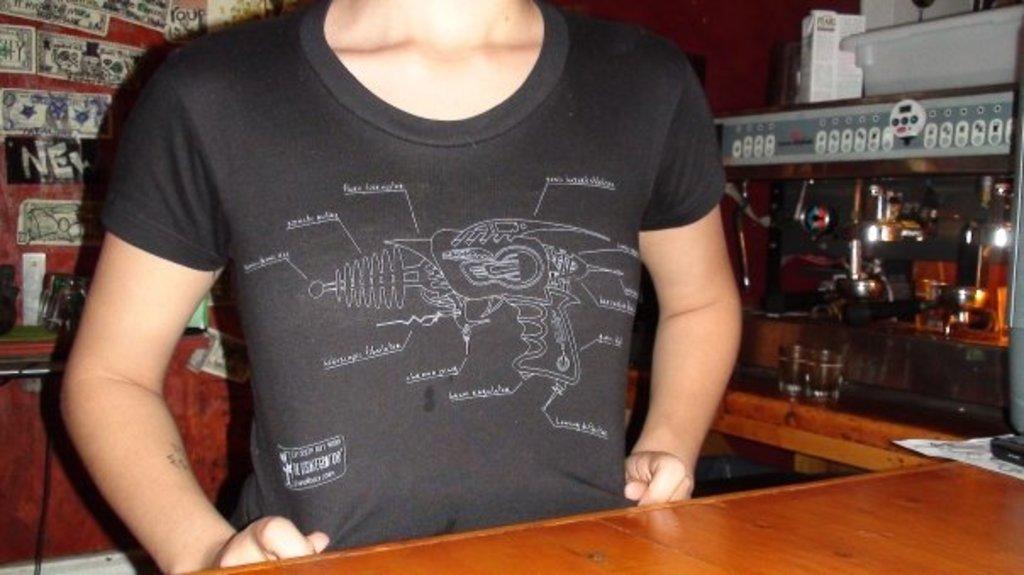Could you give a brief overview of what you see in this image? In the image we can see a person wearing clothes. Here we can see wooden surface, glasses, cable wire and other things. 